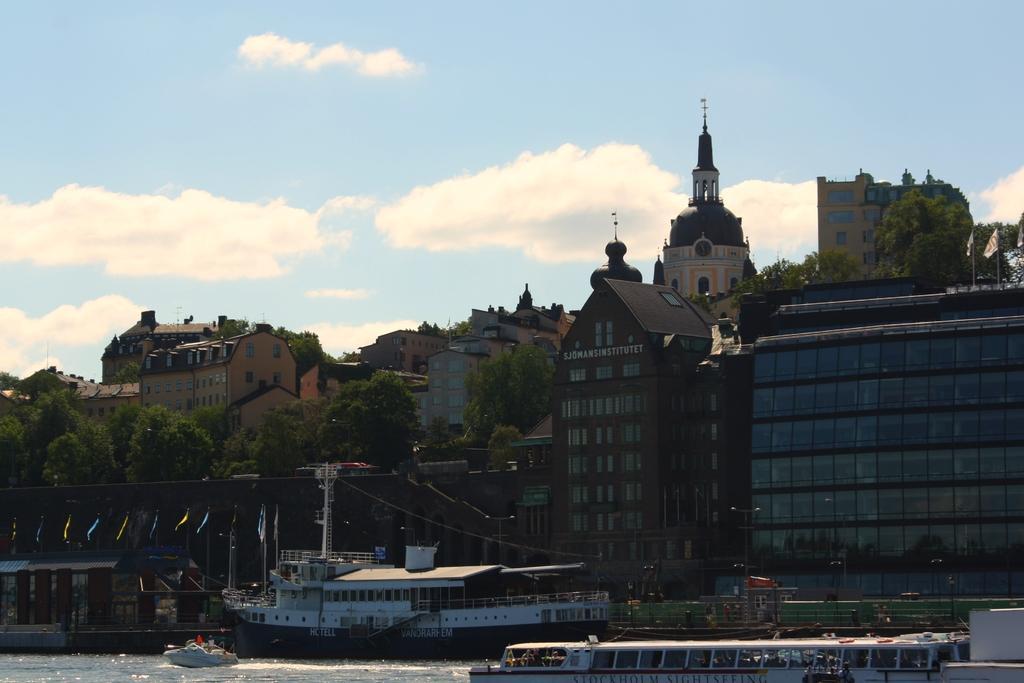Describe this image in one or two sentences. This is the picture of a city. In this image there are boats on the water and at the back there are flags, buildings, trees and poles. At the top there is sky and there are clouds. At the bottom there is water. 